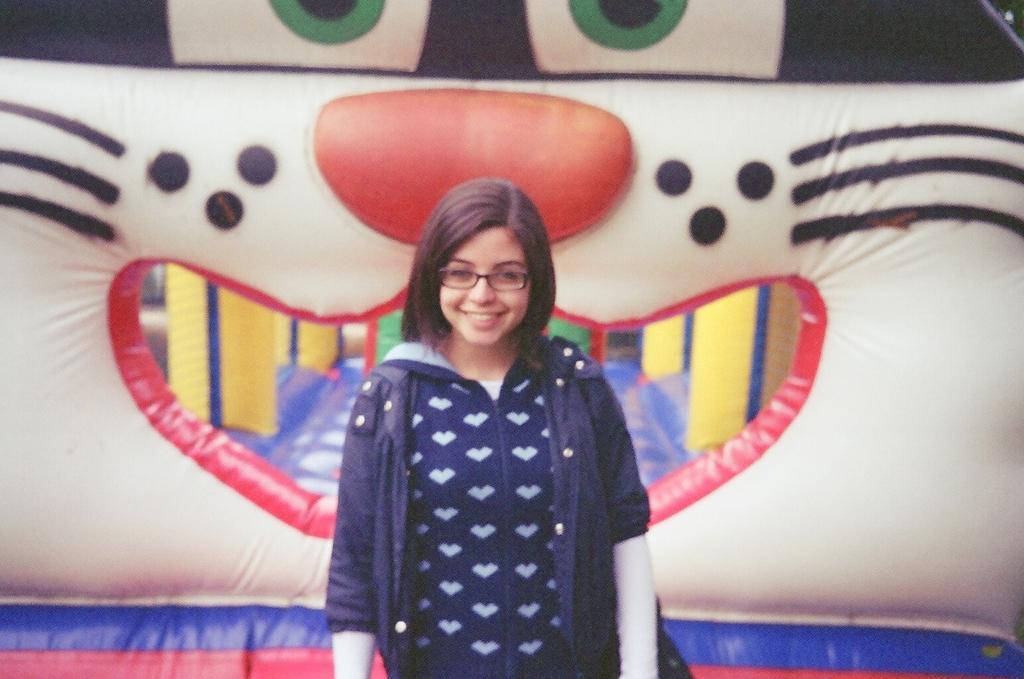In one or two sentences, can you explain what this image depicts? In the image we can see a woman standing, wearing clothes and spectacles. Behind her we can see inflatable teddy. 